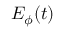Convert formula to latex. <formula><loc_0><loc_0><loc_500><loc_500>E _ { \phi } ( t )</formula> 